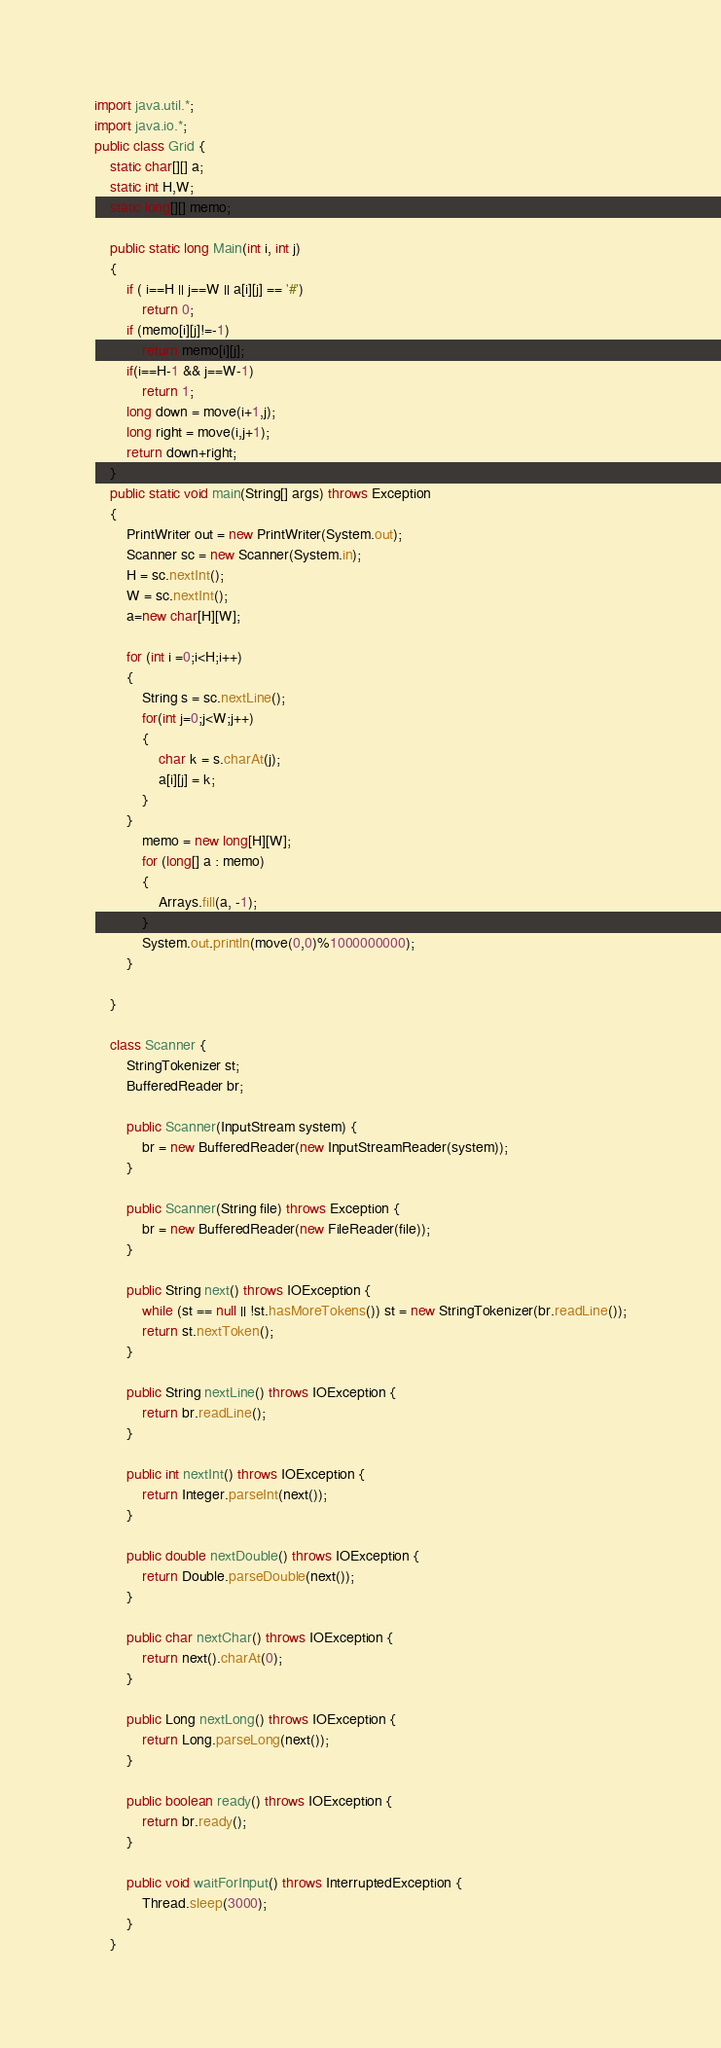<code> <loc_0><loc_0><loc_500><loc_500><_Java_>import java.util.*;
import java.io.*;
public class Grid {
	static char[][] a;
	static int H,W;
	static long[][] memo;

	public static long Main(int i, int j)
	{
		if ( i==H || j==W || a[i][j] == '#')
			return 0;
		if (memo[i][j]!=-1)
			return memo[i][j];
		if(i==H-1 && j==W-1)
			return 1;
		long down = move(i+1,j);
		long right = move(i,j+1);
		return down+right;
	}
	public static void main(String[] args) throws Exception
	{
		PrintWriter out = new PrintWriter(System.out);
		Scanner sc = new Scanner(System.in);
		H = sc.nextInt();
		W = sc.nextInt();
		a=new char[H][W]; 

		for (int i =0;i<H;i++)
		{
			String s = sc.nextLine();
			for(int j=0;j<W;j++)
			{
				char k = s.charAt(j);
				a[i][j] = k;
			}
		}
			memo = new long[H][W];
			for (long[] a : memo)
			{
				Arrays.fill(a, -1);
			}
			System.out.println(move(0,0)%1000000000);
		}

	}

	class Scanner {
		StringTokenizer st;
		BufferedReader br;

		public Scanner(InputStream system) {
			br = new BufferedReader(new InputStreamReader(system));
		}

		public Scanner(String file) throws Exception {
			br = new BufferedReader(new FileReader(file));
		}

		public String next() throws IOException {
			while (st == null || !st.hasMoreTokens()) st = new StringTokenizer(br.readLine());
			return st.nextToken();
		}

		public String nextLine() throws IOException {
			return br.readLine();
		}

		public int nextInt() throws IOException {
			return Integer.parseInt(next());
		}

		public double nextDouble() throws IOException {
			return Double.parseDouble(next());
		}

		public char nextChar() throws IOException {
			return next().charAt(0);
		}

		public Long nextLong() throws IOException {
			return Long.parseLong(next());
		}

		public boolean ready() throws IOException {
			return br.ready();
		}

		public void waitForInput() throws InterruptedException {
			Thread.sleep(3000);
		}
	}</code> 